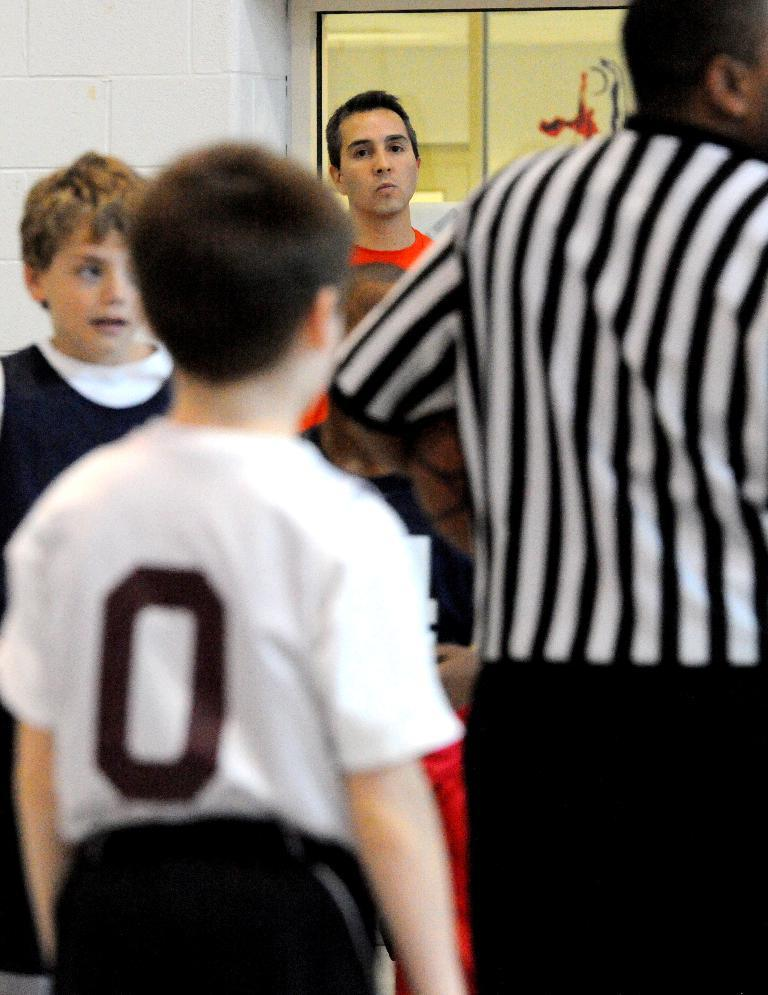Who or what can be seen in the image? There are people in the image. What colors are the dresses of some of the people wearing? Some of the people are wearing black, white, or orange color dresses. What is visible in the background of the image? There is a glass door and a wall in the background of the image. How does the snail offer its services in the image? There is no snail present in the image, so it cannot offer any services. 